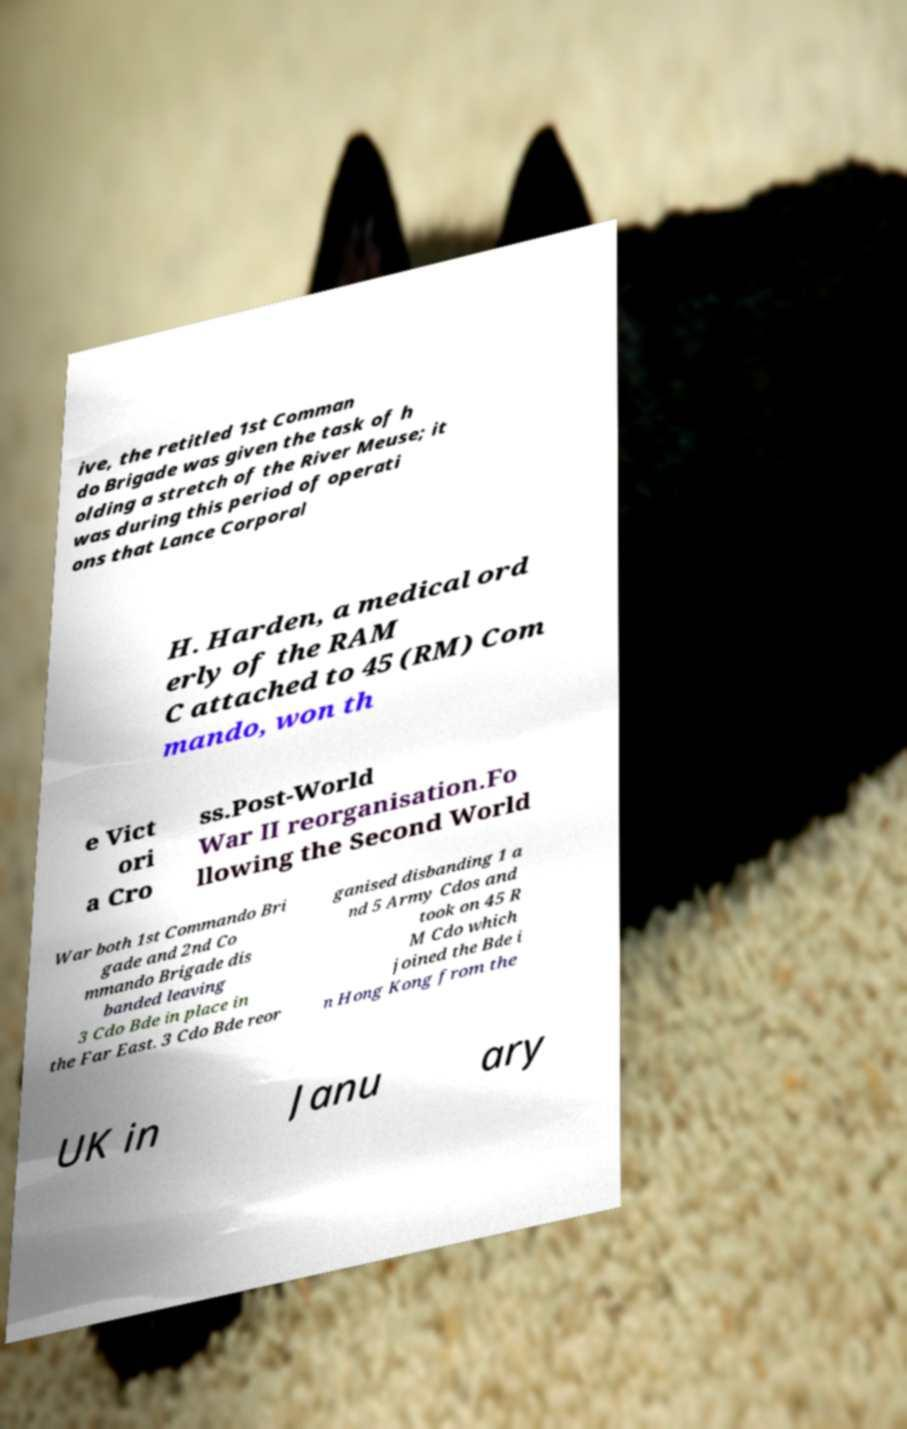Could you assist in decoding the text presented in this image and type it out clearly? ive, the retitled 1st Comman do Brigade was given the task of h olding a stretch of the River Meuse; it was during this period of operati ons that Lance Corporal H. Harden, a medical ord erly of the RAM C attached to 45 (RM) Com mando, won th e Vict ori a Cro ss.Post-World War II reorganisation.Fo llowing the Second World War both 1st Commando Bri gade and 2nd Co mmando Brigade dis banded leaving 3 Cdo Bde in place in the Far East. 3 Cdo Bde reor ganised disbanding 1 a nd 5 Army Cdos and took on 45 R M Cdo which joined the Bde i n Hong Kong from the UK in Janu ary 